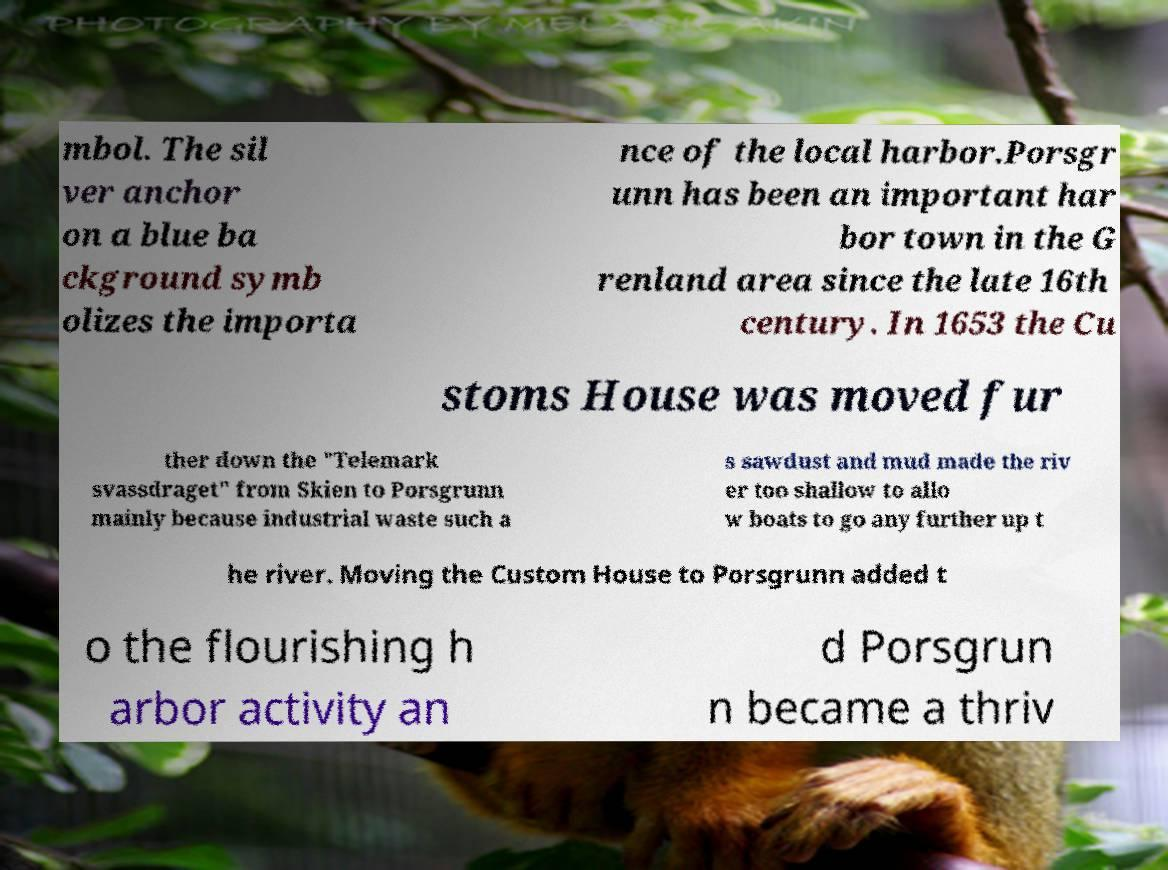Can you read and provide the text displayed in the image?This photo seems to have some interesting text. Can you extract and type it out for me? mbol. The sil ver anchor on a blue ba ckground symb olizes the importa nce of the local harbor.Porsgr unn has been an important har bor town in the G renland area since the late 16th century. In 1653 the Cu stoms House was moved fur ther down the "Telemark svassdraget" from Skien to Porsgrunn mainly because industrial waste such a s sawdust and mud made the riv er too shallow to allo w boats to go any further up t he river. Moving the Custom House to Porsgrunn added t o the flourishing h arbor activity an d Porsgrun n became a thriv 